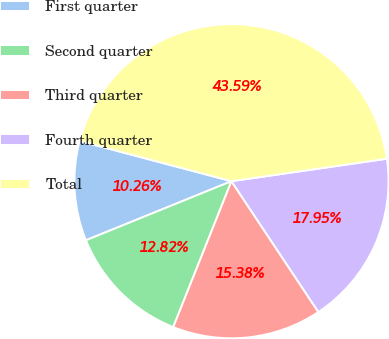Convert chart to OTSL. <chart><loc_0><loc_0><loc_500><loc_500><pie_chart><fcel>First quarter<fcel>Second quarter<fcel>Third quarter<fcel>Fourth quarter<fcel>Total<nl><fcel>10.26%<fcel>12.82%<fcel>15.38%<fcel>17.95%<fcel>43.59%<nl></chart> 